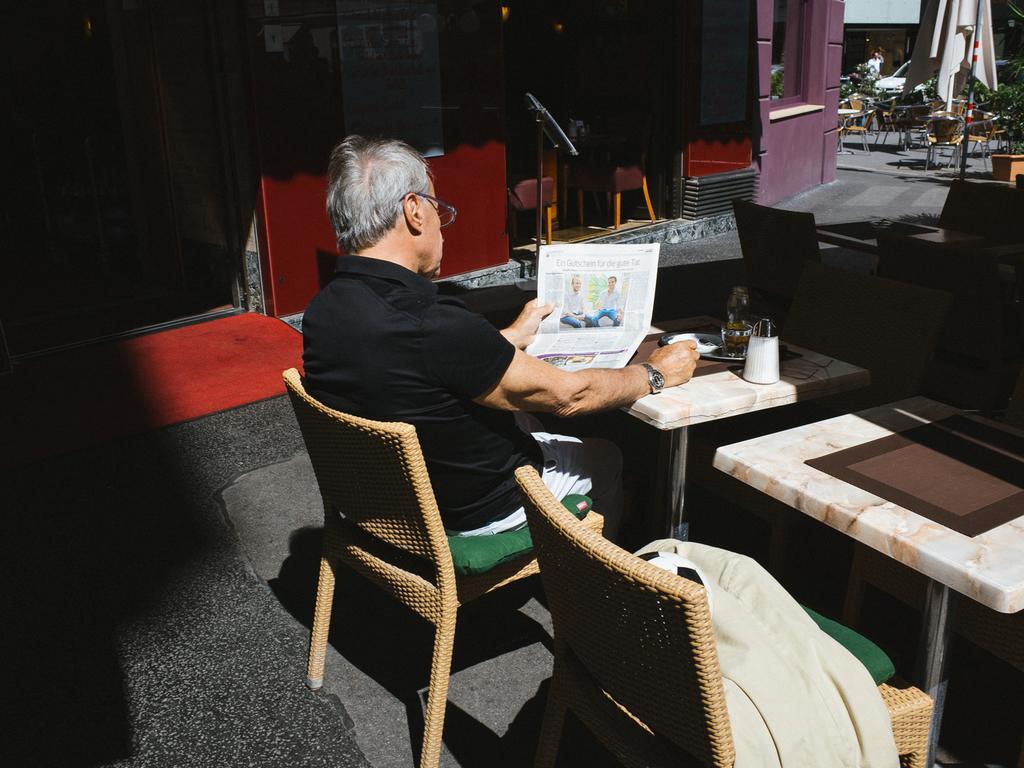How would you summarize this image in a sentence or two? This person sitting on the chair and holding paper. We can see tables and chairs,on the table we can see jar,plate. On the background we can see wall,door,glass window. A far we can see chairs,person ,vehicle,trees. 